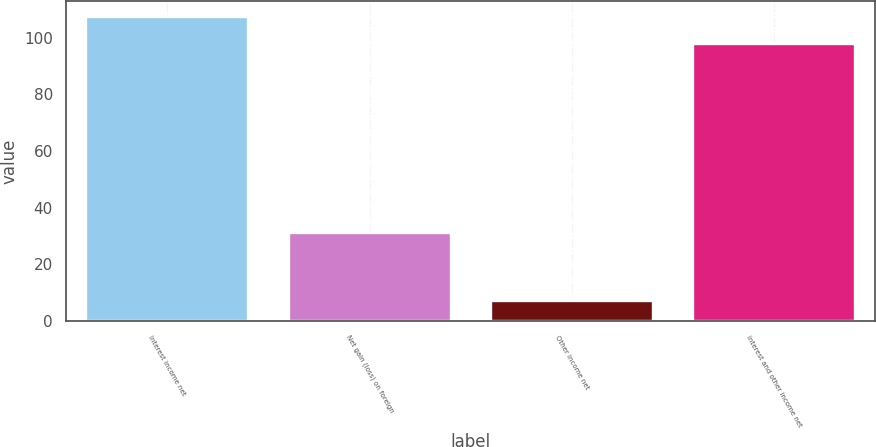Convert chart. <chart><loc_0><loc_0><loc_500><loc_500><bar_chart><fcel>Interest income net<fcel>Net gain (loss) on foreign<fcel>Other income net<fcel>Interest and other income net<nl><fcel>107.5<fcel>31<fcel>7<fcel>98<nl></chart> 